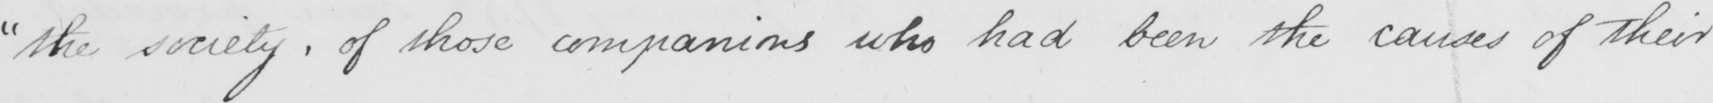What does this handwritten line say? " the society , of those companions who had been the causes of their 